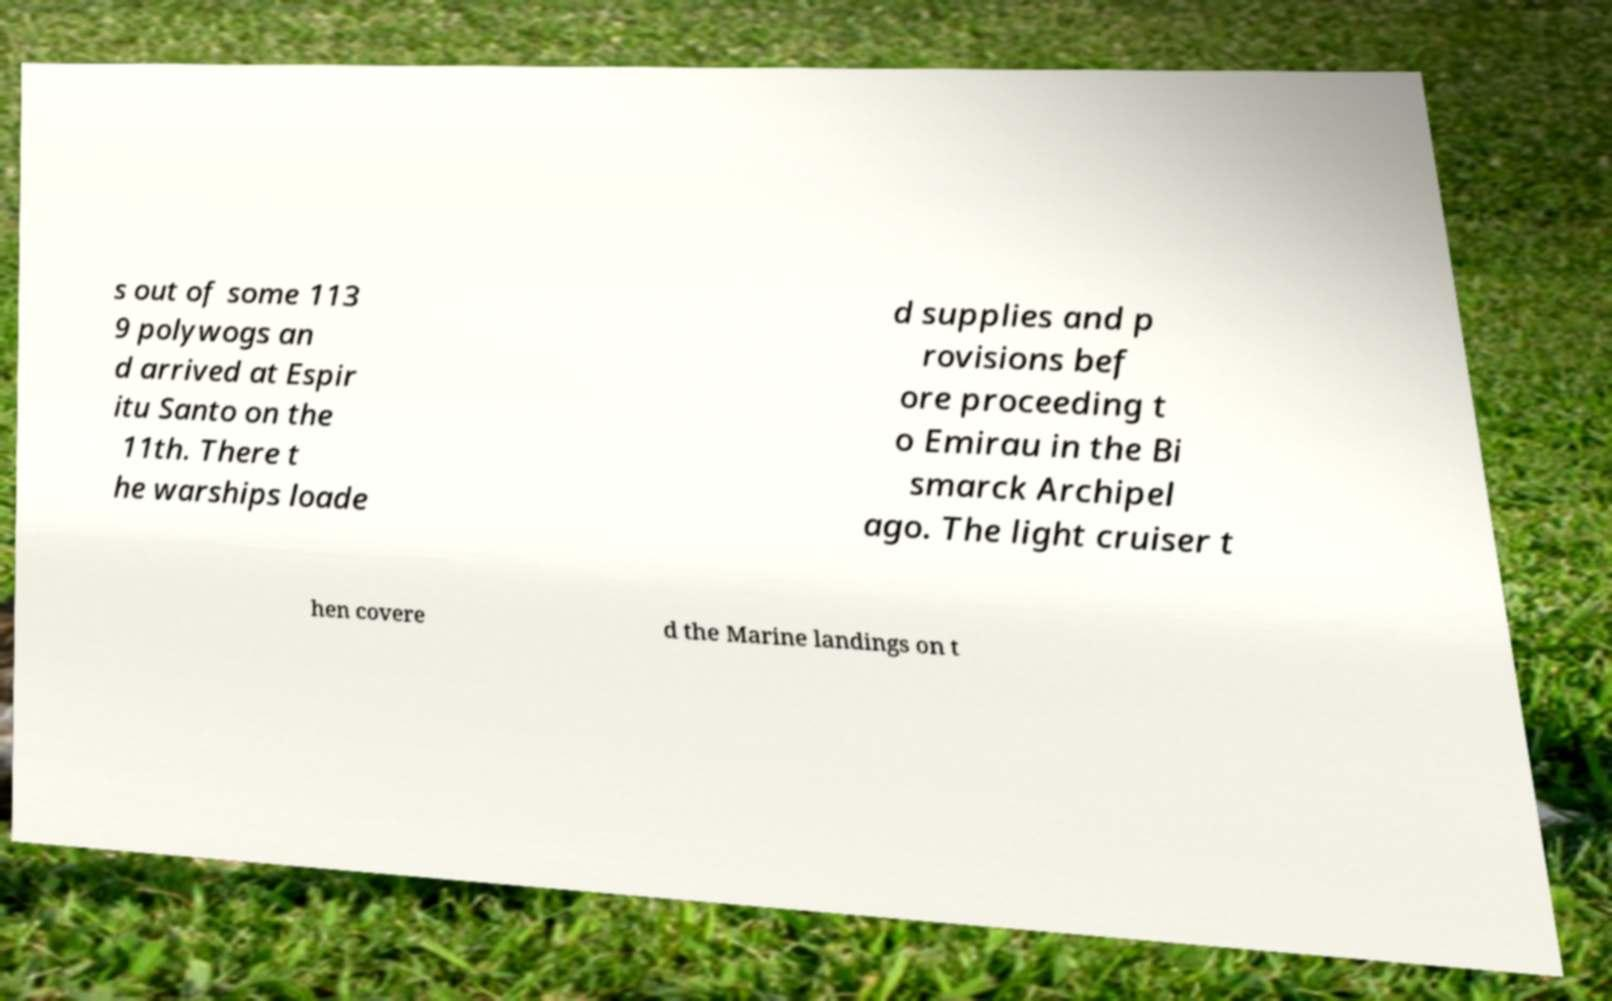Can you read and provide the text displayed in the image?This photo seems to have some interesting text. Can you extract and type it out for me? s out of some 113 9 polywogs an d arrived at Espir itu Santo on the 11th. There t he warships loade d supplies and p rovisions bef ore proceeding t o Emirau in the Bi smarck Archipel ago. The light cruiser t hen covere d the Marine landings on t 